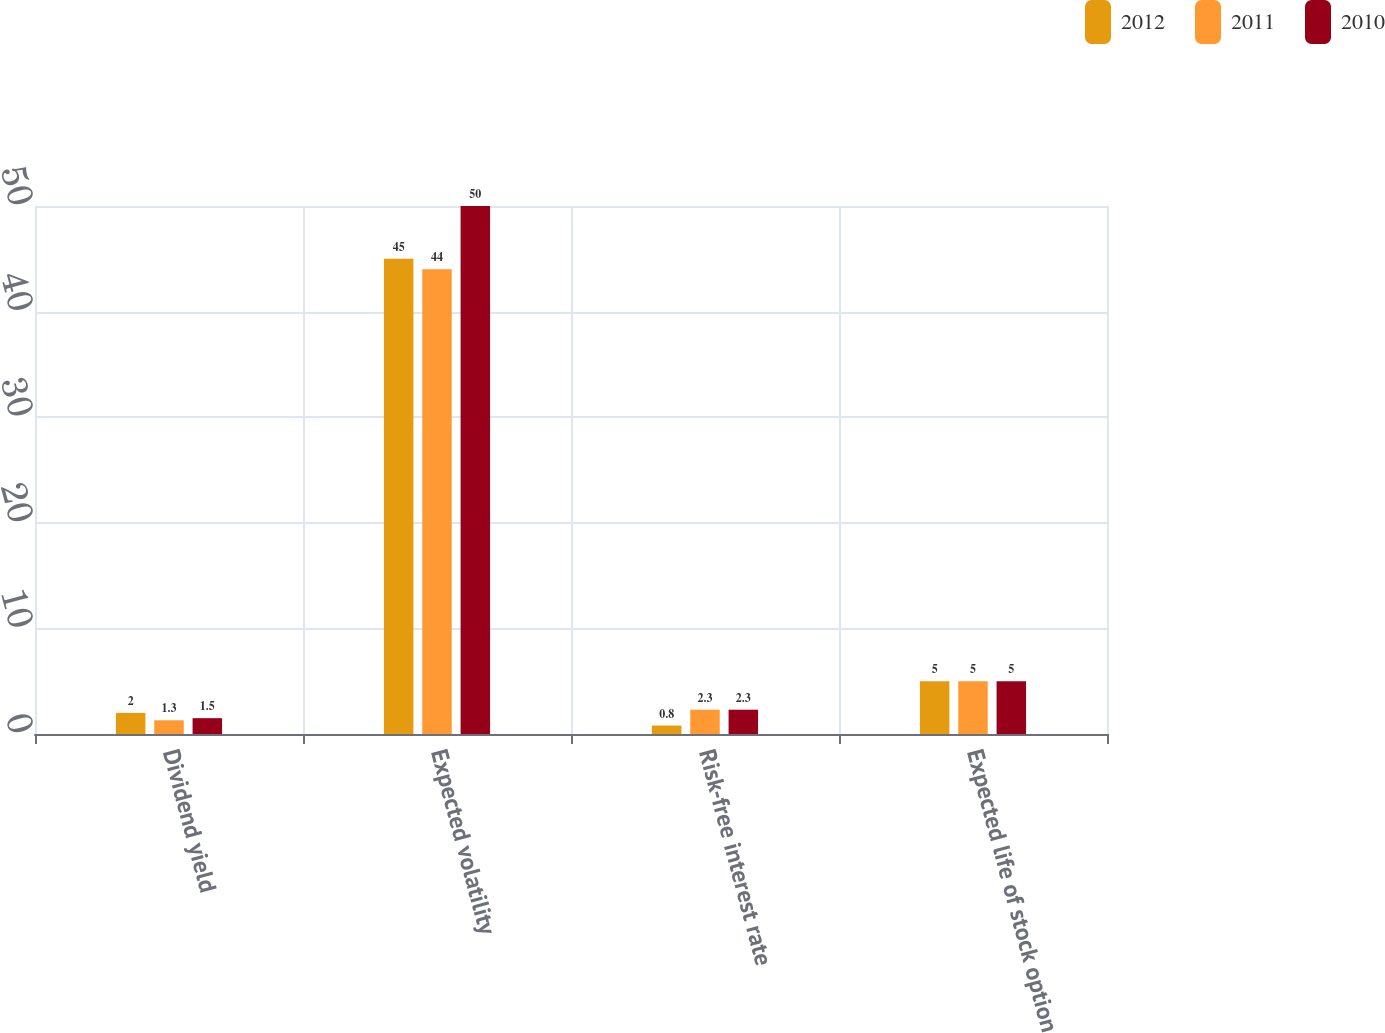Convert chart to OTSL. <chart><loc_0><loc_0><loc_500><loc_500><stacked_bar_chart><ecel><fcel>Dividend yield<fcel>Expected volatility<fcel>Risk-free interest rate<fcel>Expected life of stock option<nl><fcel>2012<fcel>2<fcel>45<fcel>0.8<fcel>5<nl><fcel>2011<fcel>1.3<fcel>44<fcel>2.3<fcel>5<nl><fcel>2010<fcel>1.5<fcel>50<fcel>2.3<fcel>5<nl></chart> 